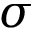Convert formula to latex. <formula><loc_0><loc_0><loc_500><loc_500>\sigma</formula> 